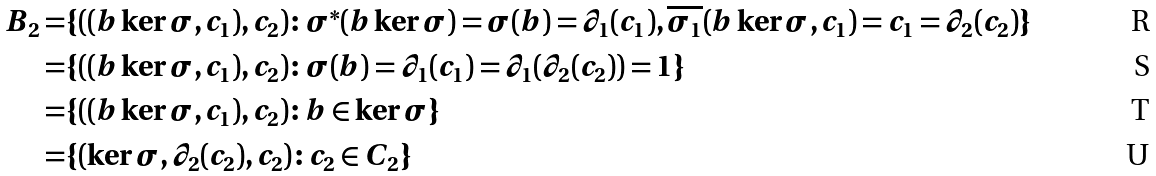<formula> <loc_0><loc_0><loc_500><loc_500>B _ { 2 } = & \{ ( ( b \ker \sigma , c _ { 1 } ) , c _ { 2 } ) \colon \sigma ^ { * } ( b \ker \sigma ) = \sigma ( b ) = \partial _ { 1 } ( c _ { 1 } ) , \overline { \sigma _ { 1 } } ( b \ker \sigma , c _ { 1 } ) = c _ { 1 } = \partial _ { 2 } ( c _ { 2 } ) \} \\ = & \{ ( ( b \ker \sigma , c _ { 1 } ) , c _ { 2 } ) \colon \sigma ( b ) = \partial _ { 1 } ( c _ { 1 } ) = \partial _ { 1 } ( \partial _ { 2 } ( c _ { 2 } ) ) = 1 \} \\ = & \{ ( ( b \ker \sigma , c _ { 1 } ) , c _ { 2 } ) \colon b \in \ker \sigma \} \\ = & \{ ( \ker \sigma , \partial _ { 2 } ( c _ { 2 } ) , c _ { 2 } ) \colon c _ { 2 } \in C _ { 2 } \}</formula> 